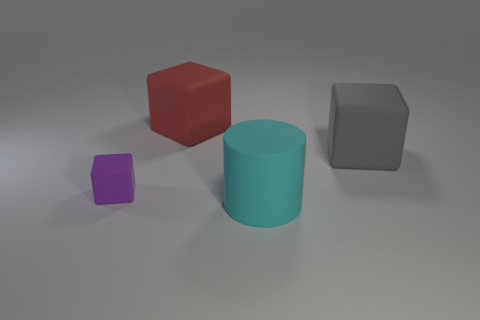Subtract all brown cylinders. Subtract all yellow balls. How many cylinders are left? 1 Add 4 tiny purple things. How many objects exist? 8 Subtract all cylinders. How many objects are left? 3 Add 1 large rubber objects. How many large rubber objects exist? 4 Subtract 0 yellow spheres. How many objects are left? 4 Subtract all tiny yellow rubber spheres. Subtract all tiny purple rubber blocks. How many objects are left? 3 Add 4 gray rubber cubes. How many gray rubber cubes are left? 5 